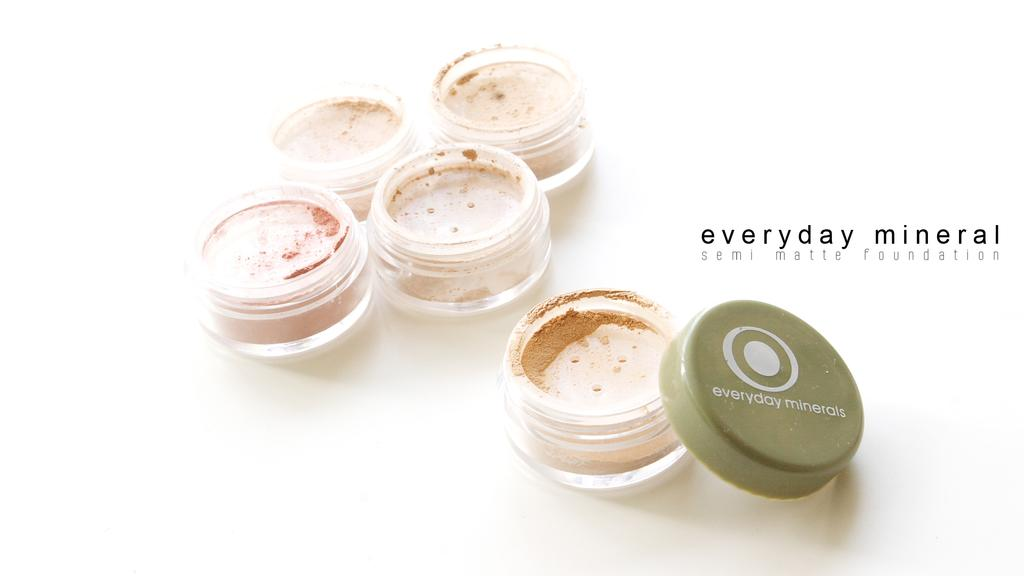What color are the boxes in the image? The boxes in the image are white. What is inside the boxes? The boxes contain foundation. What color is the cap on one of the boxes? The cap on one of the boxes is green. What is the color of the text in the image? The text in the image is black on a white background. How does the body of the glass affect the expansion of the foundation in the image? There is no glass present in the image, so the body of the glass cannot affect the expansion of the foundation. 